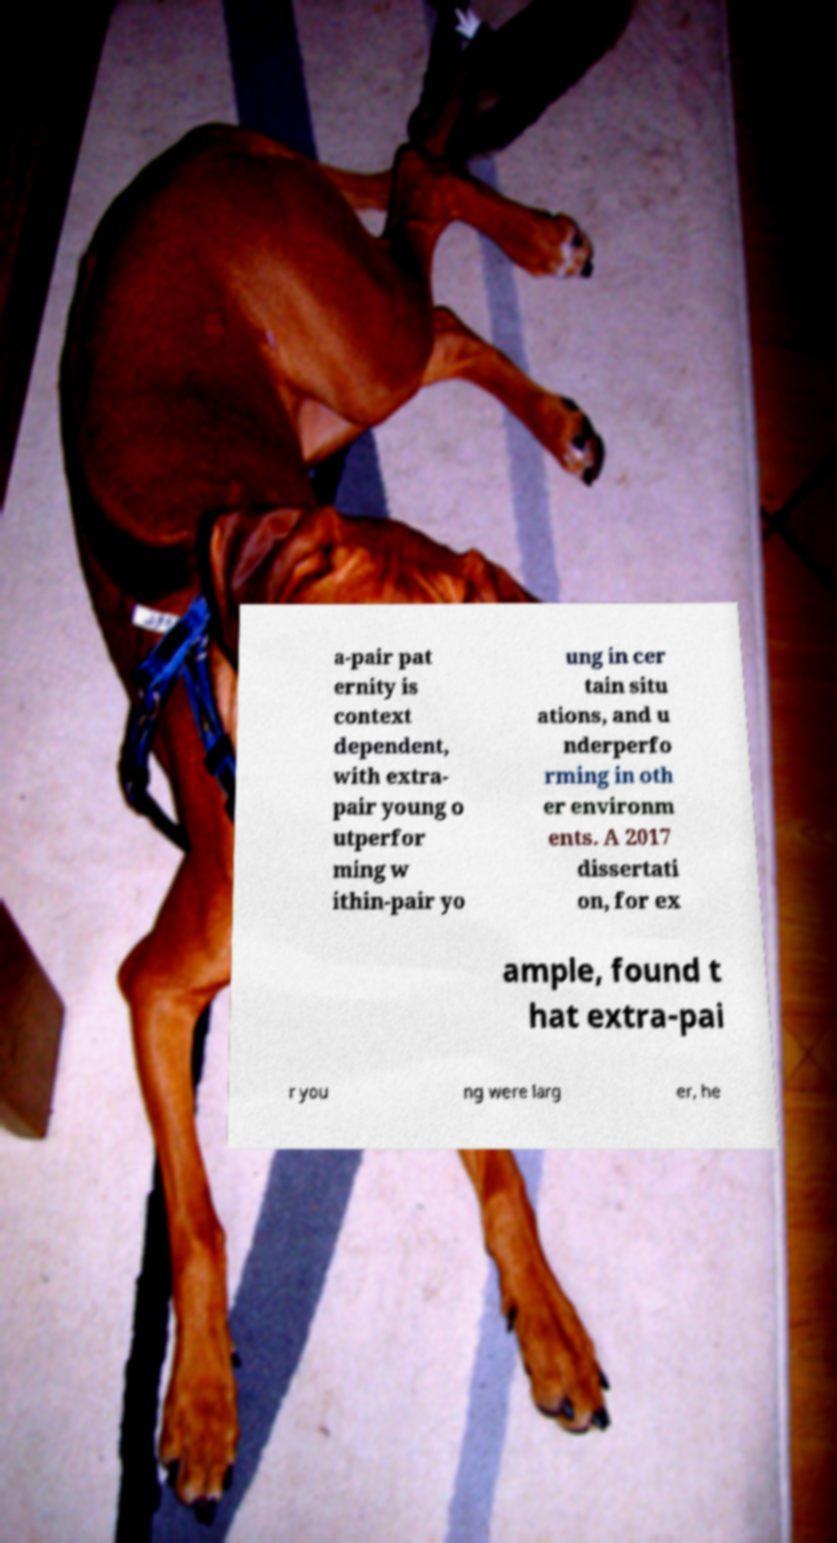Please read and relay the text visible in this image. What does it say? a-pair pat ernity is context dependent, with extra- pair young o utperfor ming w ithin-pair yo ung in cer tain situ ations, and u nderperfo rming in oth er environm ents. A 2017 dissertati on, for ex ample, found t hat extra-pai r you ng were larg er, he 